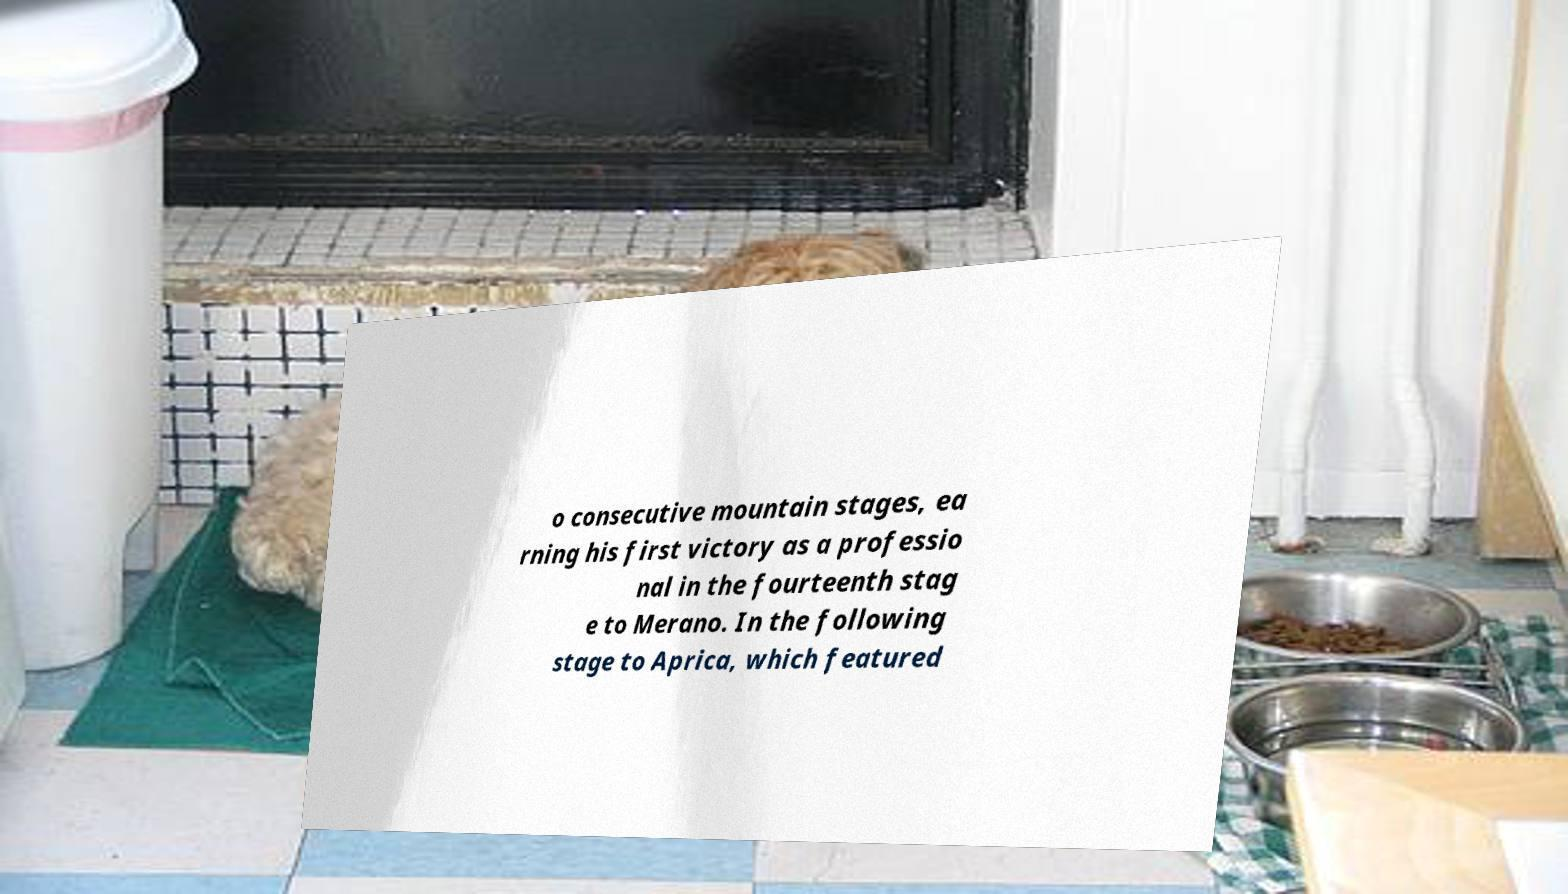There's text embedded in this image that I need extracted. Can you transcribe it verbatim? o consecutive mountain stages, ea rning his first victory as a professio nal in the fourteenth stag e to Merano. In the following stage to Aprica, which featured 